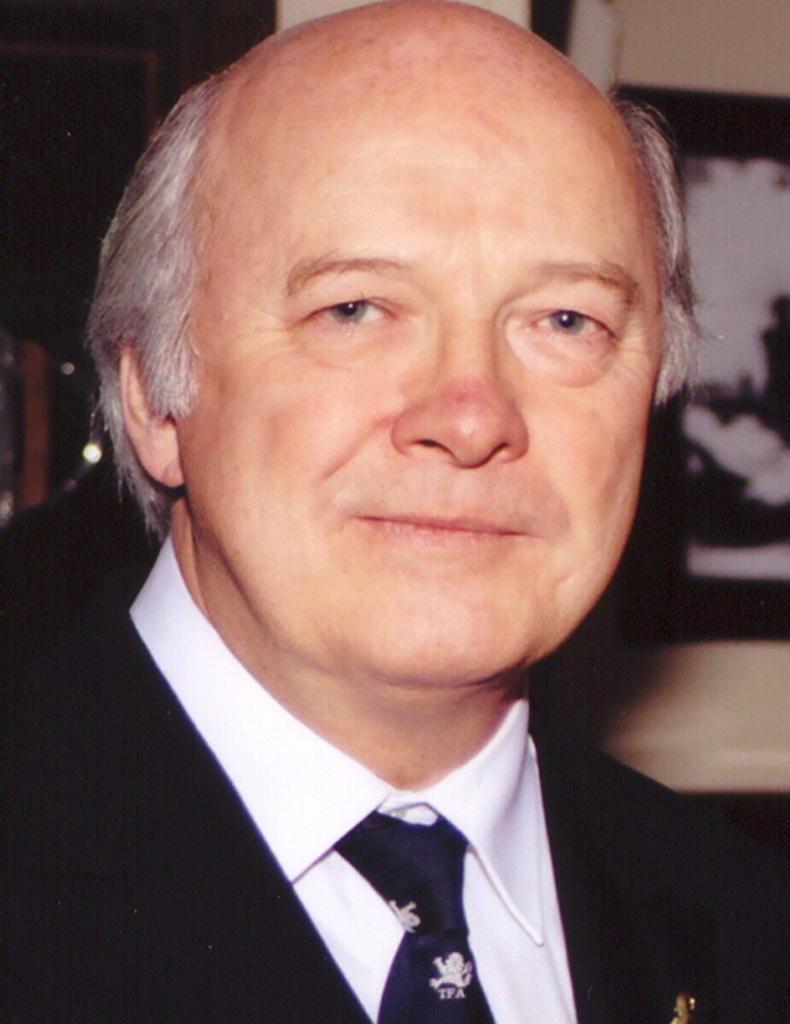Could you give a brief overview of what you see in this image? In the center of the image, we can see a person wearing a coat and a tie and in the background, there is a wall and we can see a frame. 